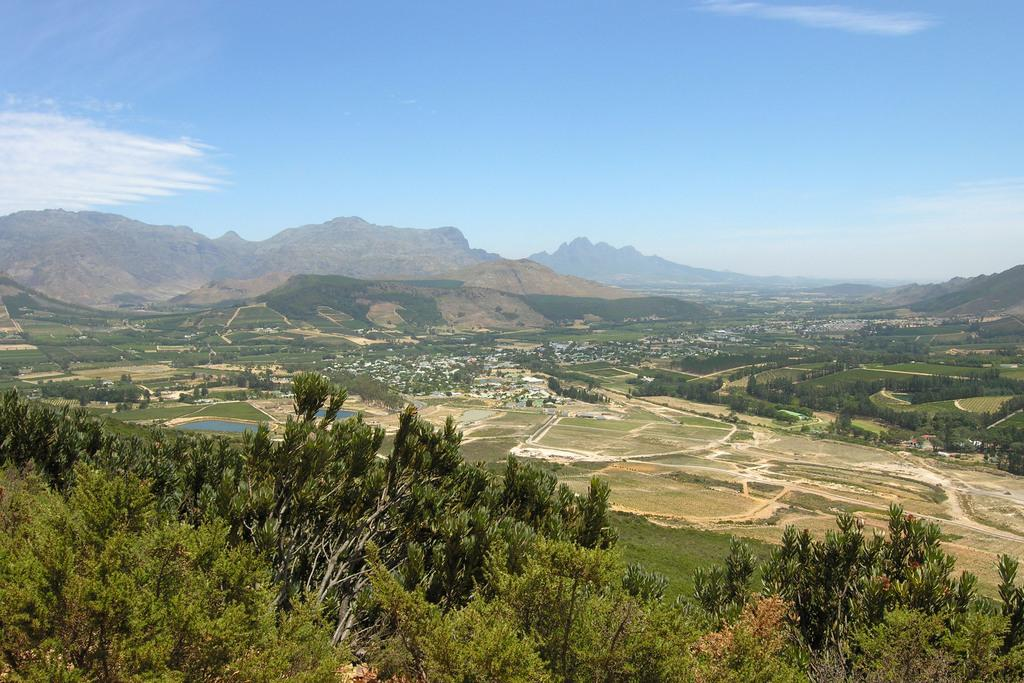What type of natural environment is depicted in the image? The image features trees, hills, and water, indicating a natural environment. Can you describe the sky in the image? The sky in the image has clouds. What is the relationship between the hills and the water in the image? The hills and water are visible in the image, but their specific relationship is not clear without more information. What type of cup is being used to control the mind in the image? There is no cup or mind control depicted in the image; it features trees, hills, water, and clouds. 